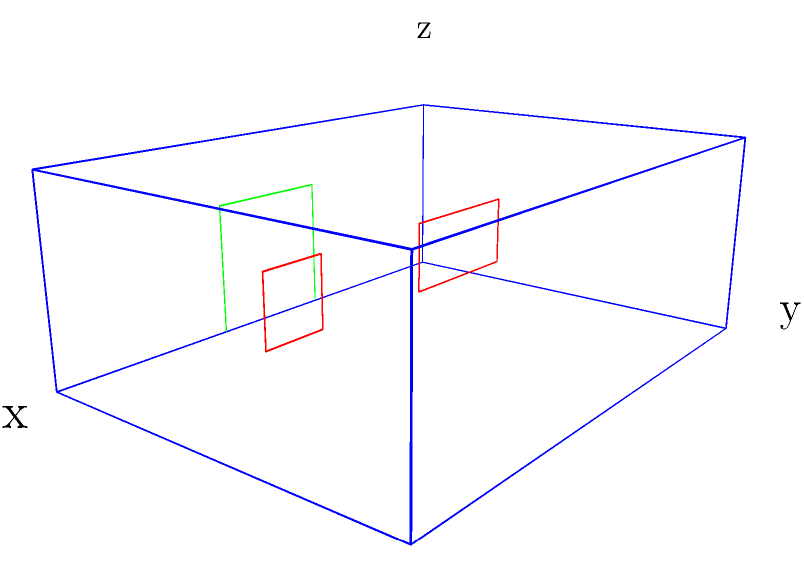In the 3D wireframe of a traditional Icelandic turf house shown above, how many rectangular windows are visible, and what is the ratio of their widths? To answer this question, we need to carefully examine the 3D wireframe of the Icelandic turf house:

1. First, identify the windows in the wireframe. Windows are typically represented as rectangular shapes on the walls.

2. In this wireframe, we can see two rectangular shapes drawn in red on one side of the house. These represent the windows.

3. Count the number of windows: There are 2 visible windows.

4. Now, we need to compare the widths of these windows:
   - The window on the left spans from x-coordinate 1 to 2, giving it a width of 1 unit.
   - The window on the right spans from x-coordinate 3 to 3.5, giving it a width of 0.5 units.

5. To find the ratio of their widths, we divide the width of the larger window by the width of the smaller window:
   $\frac{1}{0.5} = 2$

Therefore, there are 2 visible rectangular windows, and the ratio of their widths is 2:1.
Answer: 2 windows, 2:1 ratio 